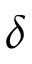Convert formula to latex. <formula><loc_0><loc_0><loc_500><loc_500>\delta</formula> 